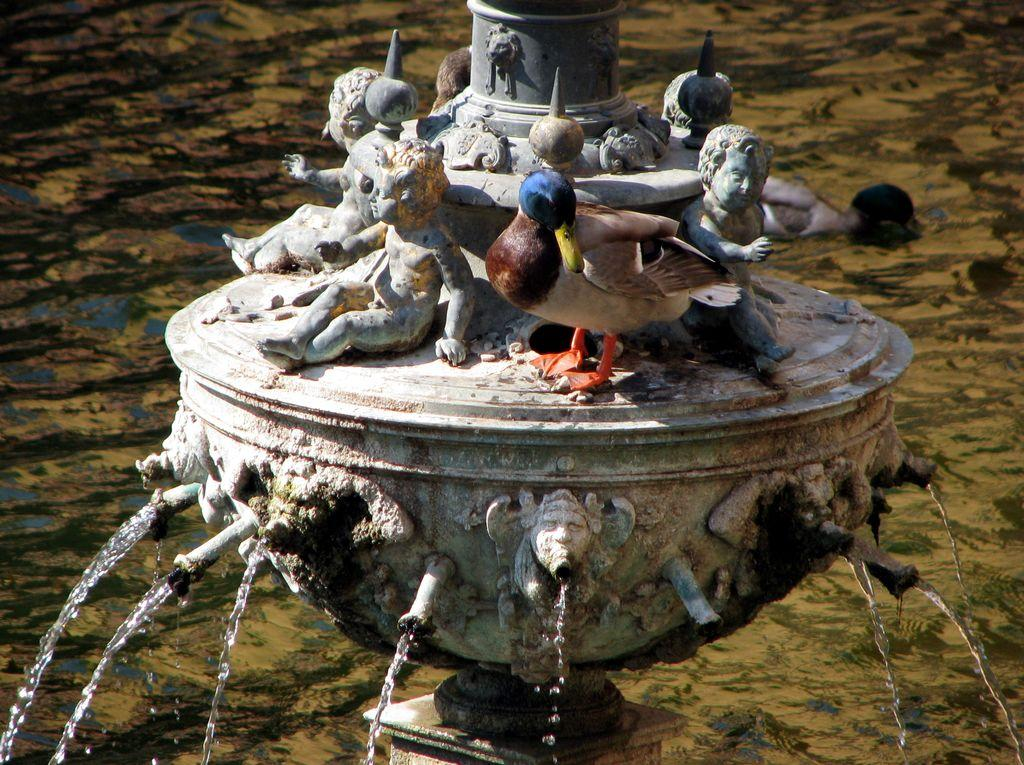What is the main subject in the center of the image? There is a fountain in the center of the image, along with sculptures and other objects. Can you describe the objects in the center of the image? The center of the image features a fountain, sculptures, and other objects. What can be seen in the background of the image? In the background of the image, there is water visible, as well as an object in the water and other objects. What type of animal can be seen swimming in the water in the background of the image? There is no animal visible in the water in the background of the image. How does the desire for water affect the objects in the image? The image does not convey any desires, as it is a static image. 